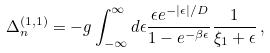Convert formula to latex. <formula><loc_0><loc_0><loc_500><loc_500>\Delta _ { n } ^ { ( 1 , 1 ) } = - g \int _ { - \infty } ^ { \infty } d \epsilon \frac { \epsilon e ^ { - | \epsilon | / D } } { 1 - e ^ { - \beta \epsilon } } \frac { 1 } { \xi _ { 1 } + \epsilon } \, ,</formula> 